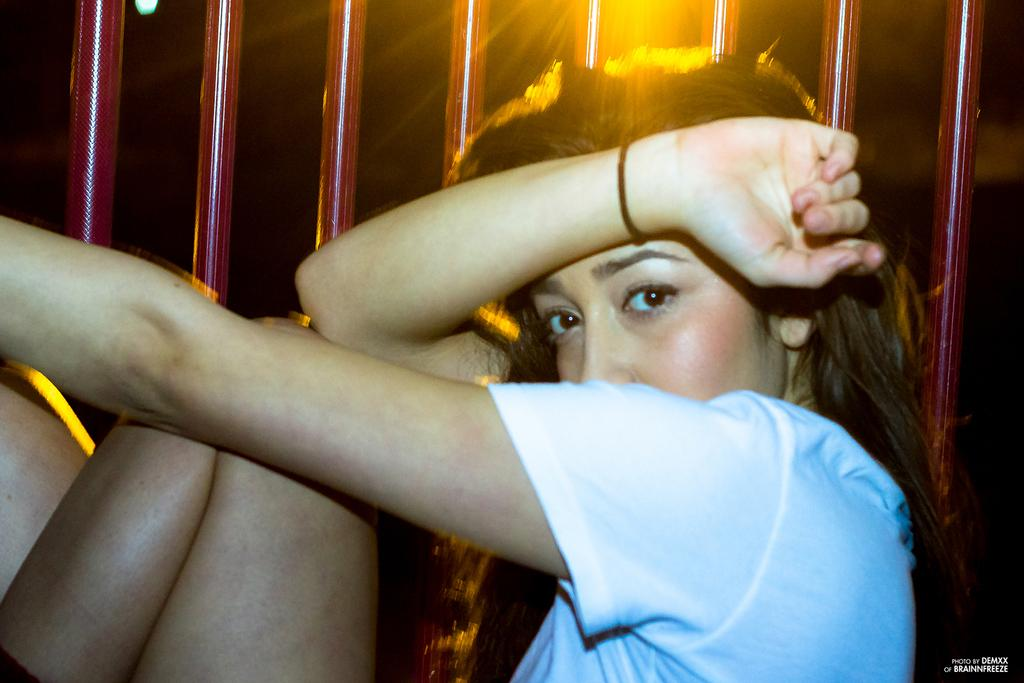What is the girl doing in the image? The girl is sitting in the image. Where is the girl sitting in relation to the wall? The girl is sitting beside a wall. What is happening at the top of the wall? Light is flashing from the top of the wall. Can you describe any additional features of the image? There is a watermark at the bottom of the image. What type of base is supporting the girl in the image? The girl is sitting on the ground, so there is no base supporting her in the image. How does the girl's scale compare to the wall in the image? The girl's scale is not explicitly compared to the wall in the image, but she appears to be sitting beside it. 